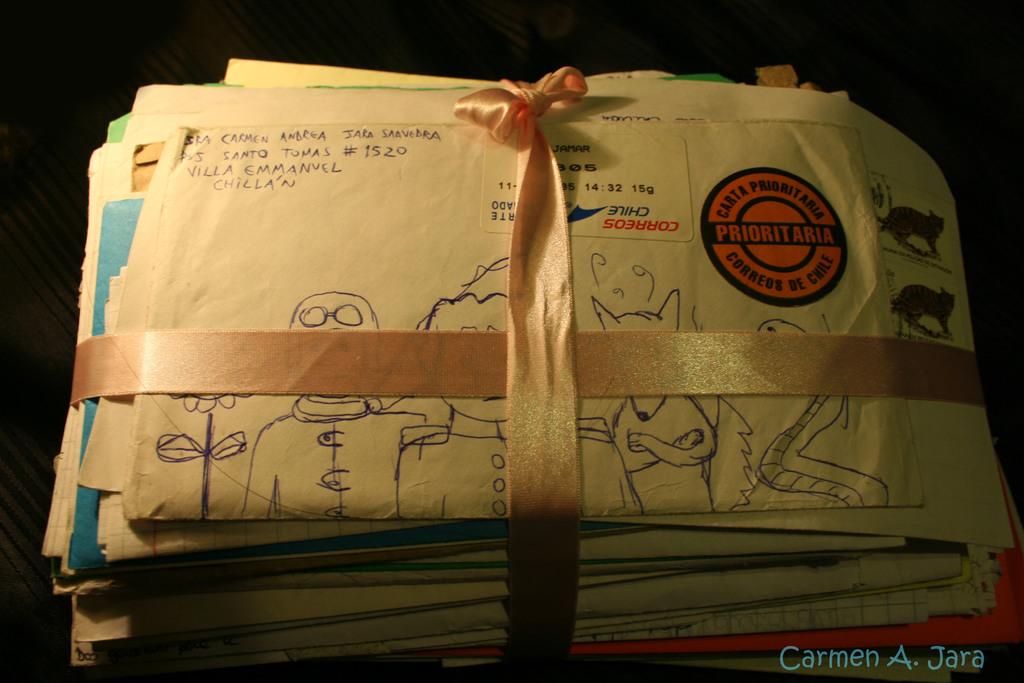Who took this photo?
Keep it short and to the point. Carmen a. jara. 